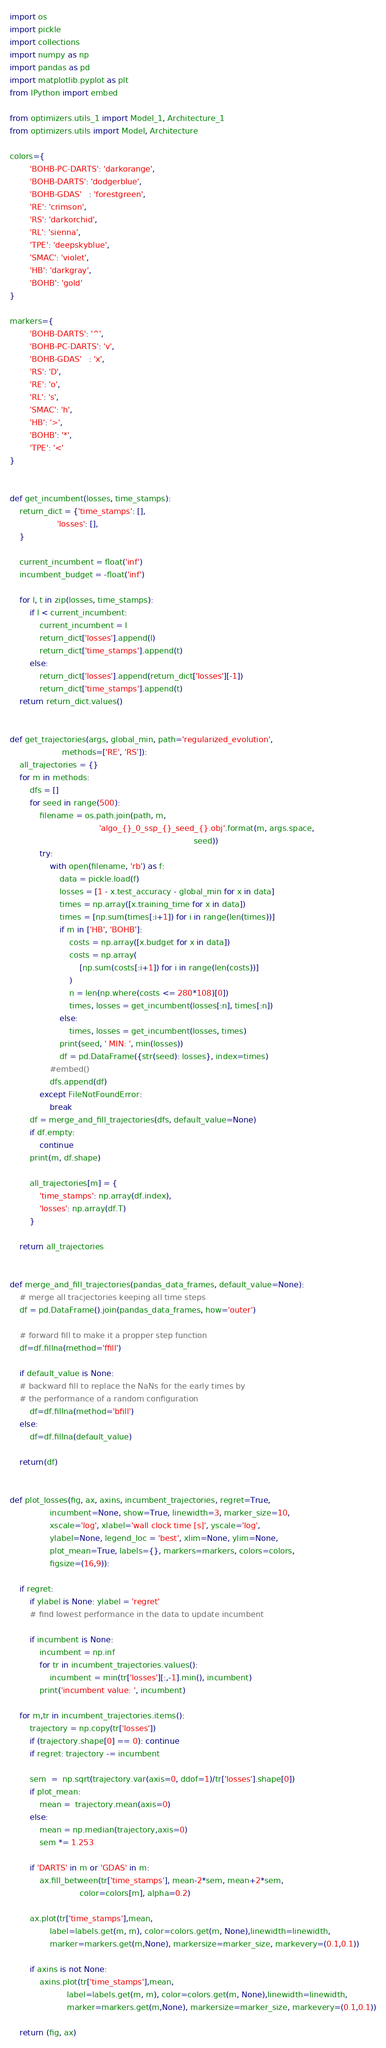<code> <loc_0><loc_0><loc_500><loc_500><_Python_>import os
import pickle
import collections
import numpy as np
import pandas as pd
import matplotlib.pyplot as plt
from IPython import embed

from optimizers.utils_1 import Model_1, Architecture_1
from optimizers.utils import Model, Architecture

colors={
        'BOHB-PC-DARTS': 'darkorange',
        'BOHB-DARTS': 'dodgerblue',
        'BOHB-GDAS'   : 'forestgreen',
        'RE': 'crimson',
		'RS': 'darkorchid',
		'RL': 'sienna',
		'TPE': 'deepskyblue',
        'SMAC': 'violet',
        'HB': 'darkgray',
        'BOHB': 'gold'
}

markers={
        'BOHB-DARTS': '^',
        'BOHB-PC-DARTS': 'v',
        'BOHB-GDAS'   : 'x',
        'RS': 'D',
		'RE': 'o',
		'RL': 's',
		'SMAC': 'h',
        'HB': '>',
        'BOHB': '*',
        'TPE': '<'
}


def get_incumbent(losses, time_stamps):
    return_dict = {'time_stamps': [],
                   'losses': [],
    }

    current_incumbent = float('inf')
    incumbent_budget = -float('inf')

    for l, t in zip(losses, time_stamps):
        if l < current_incumbent:
            current_incumbent = l
            return_dict['losses'].append(l)
            return_dict['time_stamps'].append(t)
        else:
            return_dict['losses'].append(return_dict['losses'][-1])
            return_dict['time_stamps'].append(t)
    return return_dict.values()


def get_trajectories(args, global_min, path='regularized_evolution',
                     methods=['RE', 'RS']):
    all_trajectories = {}
    for m in methods:
        dfs = []
        for seed in range(500):
            filename = os.path.join(path, m,
                                    'algo_{}_0_ssp_{}_seed_{}.obj'.format(m, args.space,
                                                                          seed))
            try:
                with open(filename, 'rb') as f:
                    data = pickle.load(f)
                    losses = [1 - x.test_accuracy - global_min for x in data]
                    times = np.array([x.training_time for x in data])
                    times = [np.sum(times[:i+1]) for i in range(len(times))]
                    if m in ['HB', 'BOHB']:
                        costs = np.array([x.budget for x in data])
                        costs = np.array(
                            [np.sum(costs[:i+1]) for i in range(len(costs))]
                        )
                        n = len(np.where(costs <= 280*108)[0])
                        times, losses = get_incumbent(losses[:n], times[:n])
                    else:
                        times, losses = get_incumbent(losses, times)
                    print(seed, ' MIN: ', min(losses))
                    df = pd.DataFrame({str(seed): losses}, index=times)
                #embed()
                dfs.append(df)
            except FileNotFoundError:
                break
        df = merge_and_fill_trajectories(dfs, default_value=None)
        if df.empty:
            continue
        print(m, df.shape)

        all_trajectories[m] = {
            'time_stamps': np.array(df.index),
            'losses': np.array(df.T)
        }

    return all_trajectories


def merge_and_fill_trajectories(pandas_data_frames, default_value=None):
	# merge all tracjectories keeping all time steps
	df = pd.DataFrame().join(pandas_data_frames, how='outer')

	# forward fill to make it a propper step function
	df=df.fillna(method='ffill')

	if default_value is None:
	# backward fill to replace the NaNs for the early times by
	# the performance of a random configuration
		df=df.fillna(method='bfill')
	else:
		df=df.fillna(default_value)

	return(df)


def plot_losses(fig, ax, axins, incumbent_trajectories, regret=True,
                incumbent=None, show=True, linewidth=3, marker_size=10,
                xscale='log', xlabel='wall clock time [s]', yscale='log',
                ylabel=None, legend_loc = 'best', xlim=None, ylim=None,
                plot_mean=True, labels={}, markers=markers, colors=colors,
                figsize=(16,9)):

    if regret:
        if ylabel is None: ylabel = 'regret'
		# find lowest performance in the data to update incumbent

        if incumbent is None:
            incumbent = np.inf
            for tr in incumbent_trajectories.values():
                incumbent = min(tr['losses'][:,-1].min(), incumbent)
            print('incumbent value: ', incumbent)

    for m,tr in incumbent_trajectories.items():
        trajectory = np.copy(tr['losses'])
        if (trajectory.shape[0] == 0): continue
        if regret: trajectory -= incumbent

        sem  =  np.sqrt(trajectory.var(axis=0, ddof=1)/tr['losses'].shape[0])
        if plot_mean:
            mean =  trajectory.mean(axis=0)
        else:
            mean = np.median(trajectory,axis=0)
            sem *= 1.253

        if 'DARTS' in m or 'GDAS' in m:
            ax.fill_between(tr['time_stamps'], mean-2*sem, mean+2*sem,
                            color=colors[m], alpha=0.2)

        ax.plot(tr['time_stamps'],mean,
                label=labels.get(m, m), color=colors.get(m, None),linewidth=linewidth,
                marker=markers.get(m,None), markersize=marker_size, markevery=(0.1,0.1))

        if axins is not None:
            axins.plot(tr['time_stamps'],mean,
                       label=labels.get(m, m), color=colors.get(m, None),linewidth=linewidth,
                       marker=markers.get(m,None), markersize=marker_size, markevery=(0.1,0.1))

    return (fig, ax)
</code> 